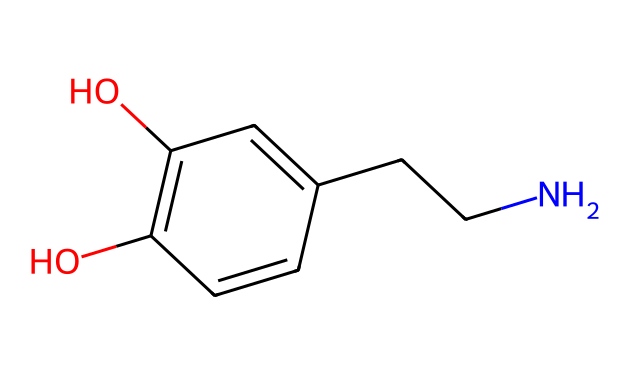What is the molecular formula of dopamine? To find the molecular formula, count the number of each type of atom represented in the SMILES. In this chemical, there are 8 carbon (C) atoms, 11 hydrogen (H) atoms, 2 oxygen (O) atoms, and 1 nitrogen (N) atom. Thus, the molecular formula is C8H11NO2.
Answer: C8H11NO2 How many rings are present in the dopamine structure? Analyzing the SMILES, we see the notation 'C1' indicating the start of a ring and 'C=C' showing connectivity without any further ring indicators. This chemical has one aromatic ring structure (the benzene part) with a total of one ring.
Answer: 1 What functional groups are present in dopamine? By examining the structure, we can identify hydroxyl (-OH) groups and an amine (-NH) group. The presence of -OH indicates it is a phenolic compound, and the -NH group indicates it contains an amine. Therefore, dopamine contains both hydroxyl and amine functional groups.
Answer: hydroxyl and amine What is the significance of the nitrogen atom in dopamine? The nitrogen atom signifies that dopamine is an amine. Amines are important in neurotransmission, affecting mood and behavior, thus indicating the neurotransmitter properties of dopamine in the brain.
Answer: amine What type of isomerism can occur in dopamine? Considering dopamine's structure, it has chirality due to the presence of the chiral carbon that could lead to different stereoisomers. However, in this particular representation, no stereoisomers are explicitly shown. Thus, the type of isomerism present is stereoisomerism.
Answer: stereoisomerism 